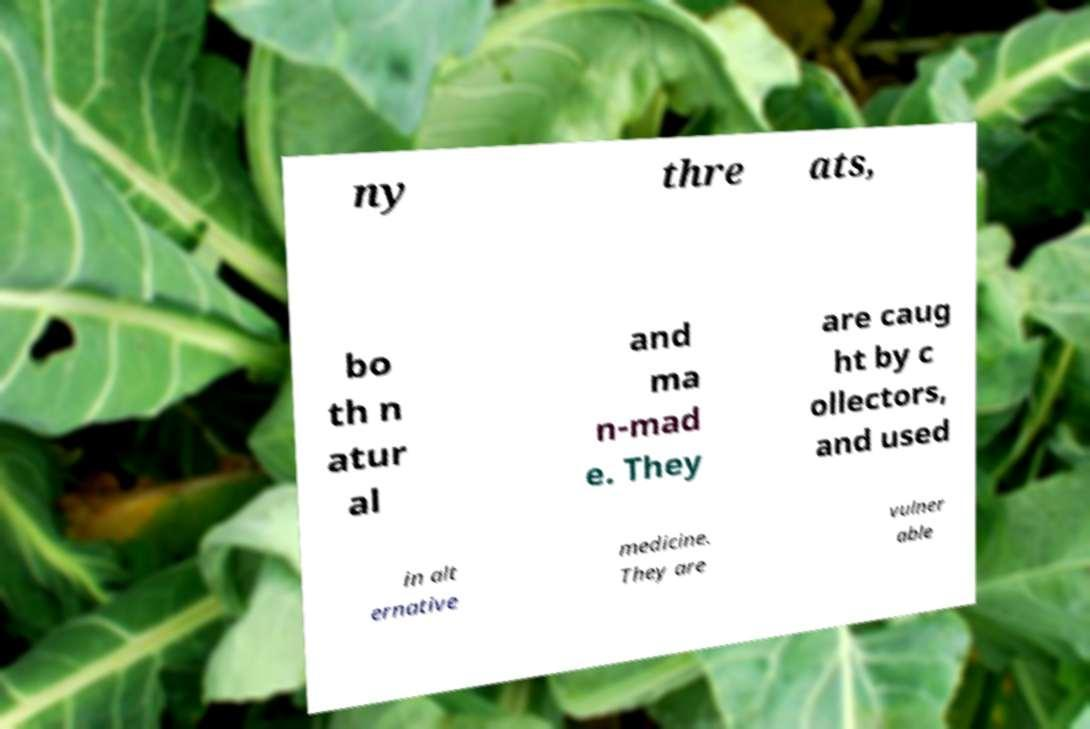I need the written content from this picture converted into text. Can you do that? ny thre ats, bo th n atur al and ma n-mad e. They are caug ht by c ollectors, and used in alt ernative medicine. They are vulner able 